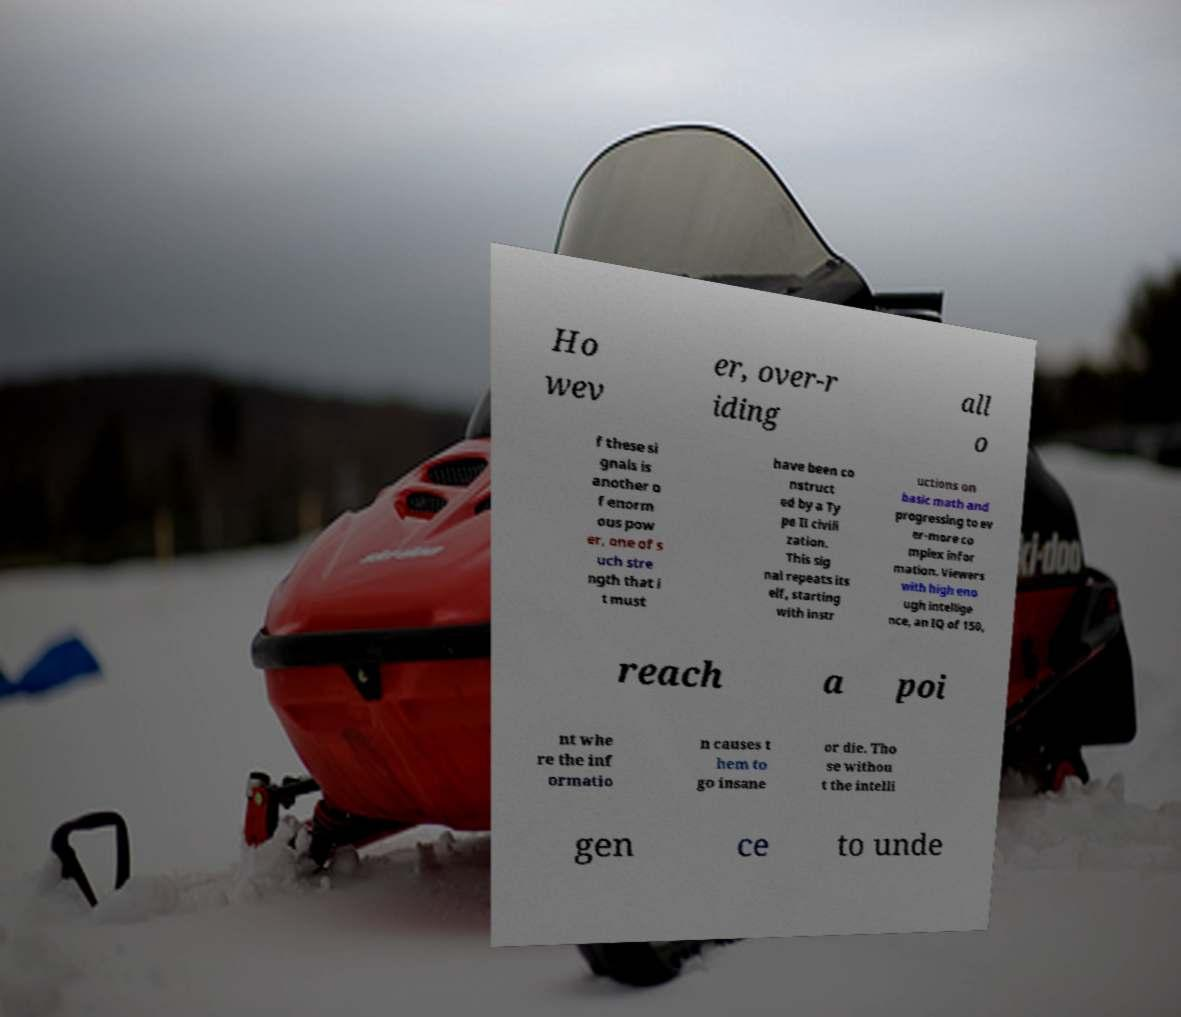I need the written content from this picture converted into text. Can you do that? Ho wev er, over-r iding all o f these si gnals is another o f enorm ous pow er, one of s uch stre ngth that i t must have been co nstruct ed by a Ty pe II civili zation. This sig nal repeats its elf, starting with instr uctions on basic math and progressing to ev er-more co mplex infor mation. Viewers with high eno ugh intellige nce, an IQ of 150, reach a poi nt whe re the inf ormatio n causes t hem to go insane or die. Tho se withou t the intelli gen ce to unde 